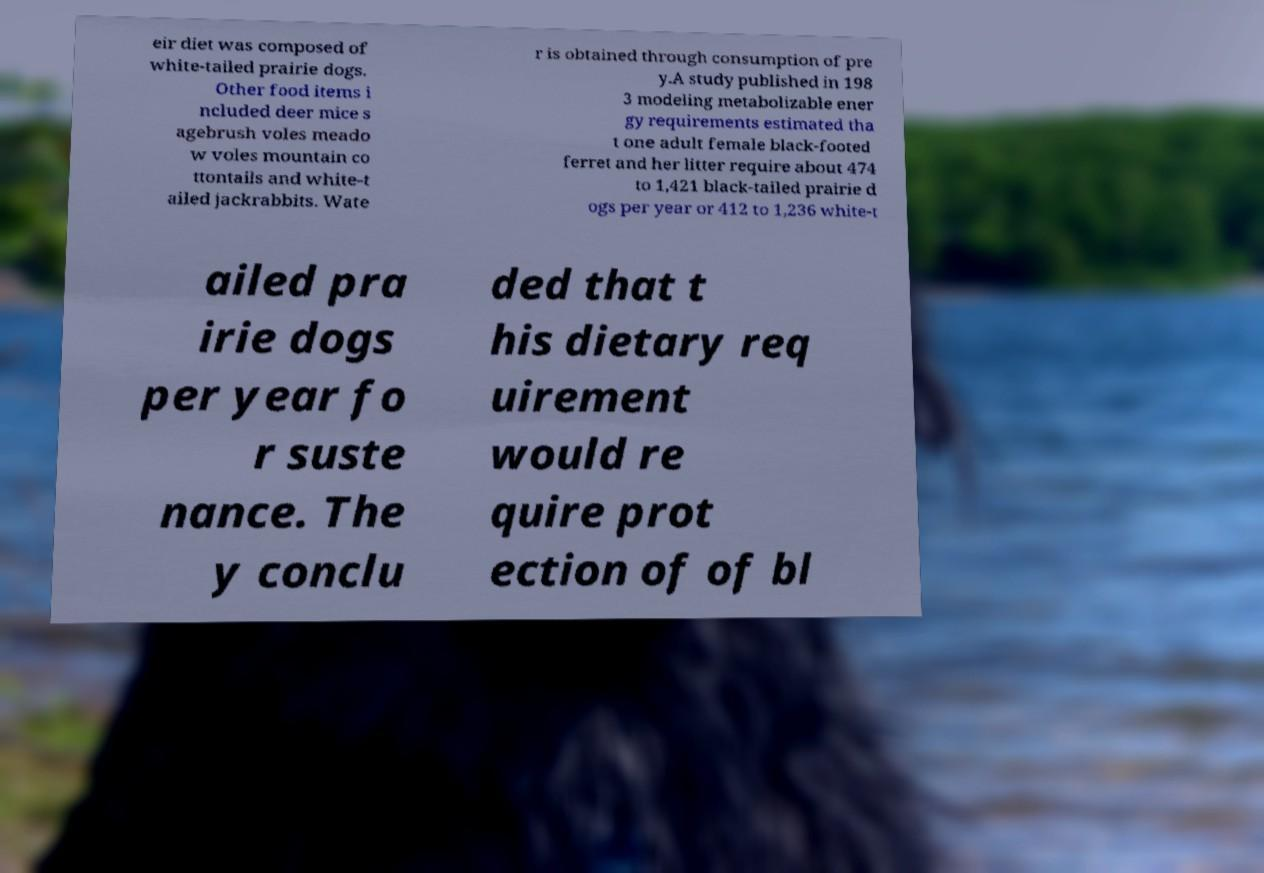What messages or text are displayed in this image? I need them in a readable, typed format. eir diet was composed of white-tailed prairie dogs. Other food items i ncluded deer mice s agebrush voles meado w voles mountain co ttontails and white-t ailed jackrabbits. Wate r is obtained through consumption of pre y.A study published in 198 3 modeling metabolizable ener gy requirements estimated tha t one adult female black-footed ferret and her litter require about 474 to 1,421 black-tailed prairie d ogs per year or 412 to 1,236 white-t ailed pra irie dogs per year fo r suste nance. The y conclu ded that t his dietary req uirement would re quire prot ection of of bl 